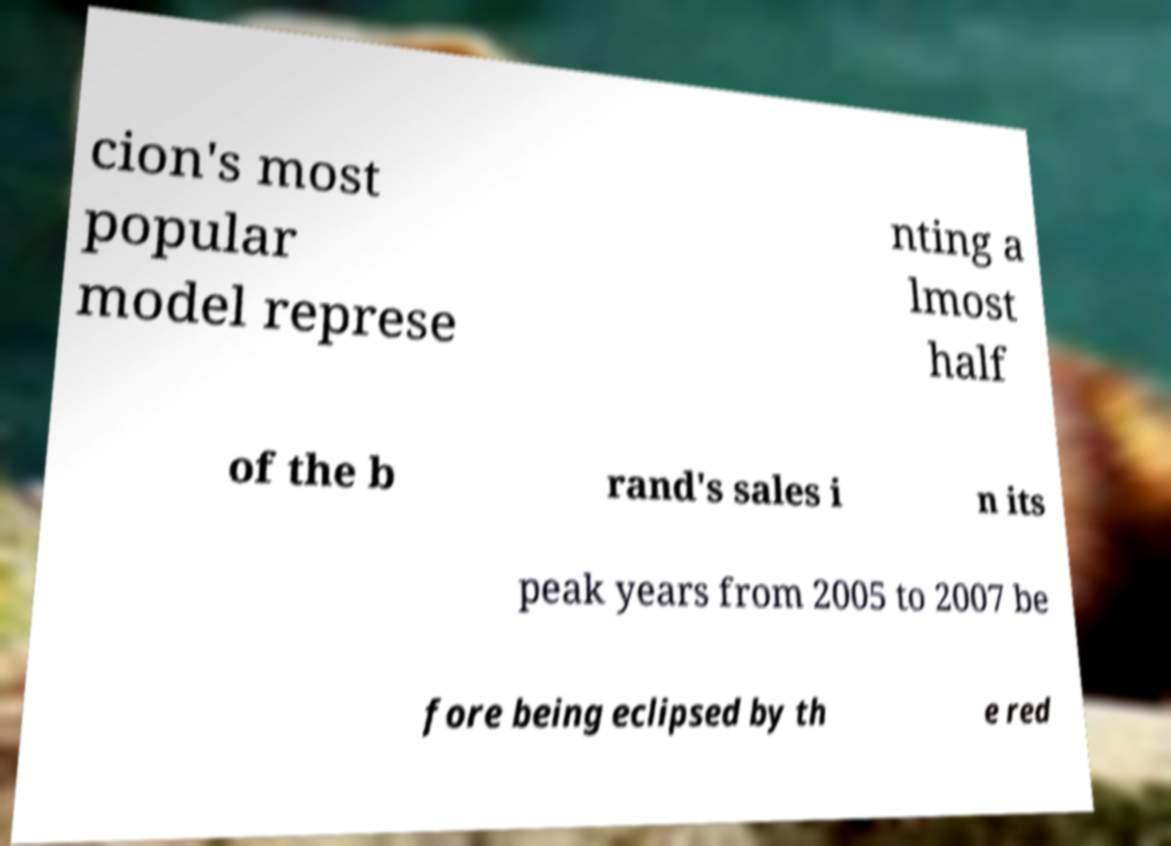Please read and relay the text visible in this image. What does it say? cion's most popular model represe nting a lmost half of the b rand's sales i n its peak years from 2005 to 2007 be fore being eclipsed by th e red 